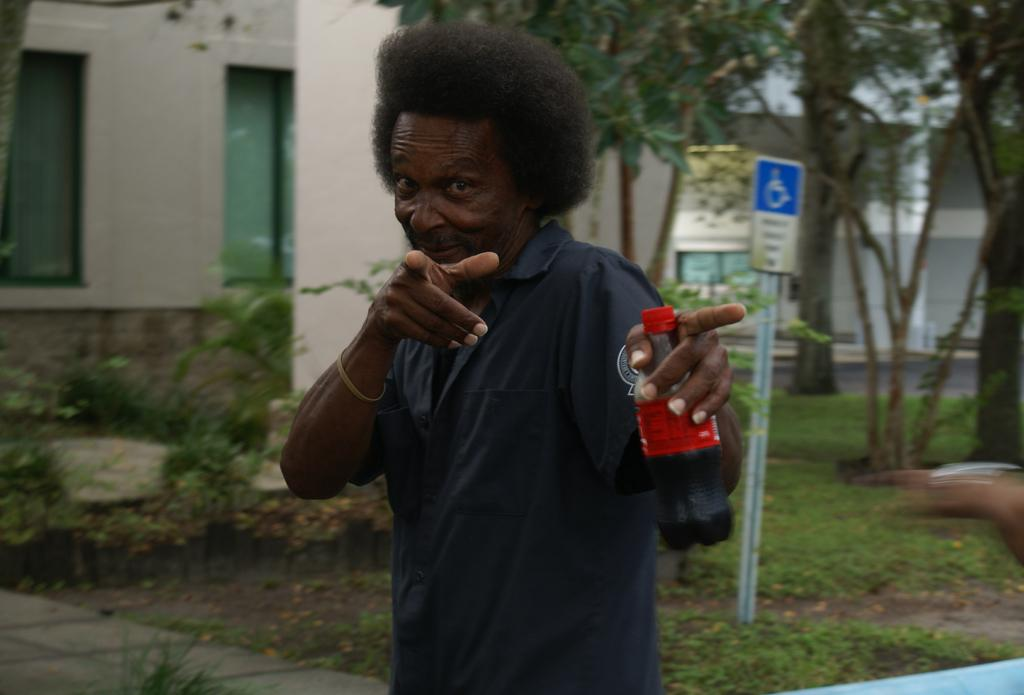What is the man in the image doing? The man is standing in the image and holding a bottle in his hand. What can be seen on the pole in the image? There is a sign board on a pole in the image. What type of vegetation is visible in the image? Trees, plants, and grass are visible in the image. What type of structures can be seen in the image? There are buildings in the image. What type of flame can be seen coming from the insect in the image? There is no insect or flame present in the image. 